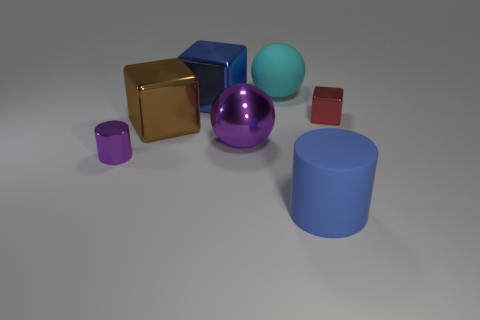What size is the sphere that is behind the object right of the thing in front of the small purple metallic object?
Your answer should be compact. Large. How big is the metal cylinder?
Your answer should be compact. Small. Is there anything else that is the same material as the tiny red thing?
Keep it short and to the point. Yes. There is a ball that is in front of the big blue thing behind the tiny metallic block; are there any purple shiny objects that are in front of it?
Offer a terse response. Yes. How many big things are either rubber balls or brown things?
Ensure brevity in your answer.  2. Is there anything else that is the same color as the tiny cylinder?
Keep it short and to the point. Yes. There is a metal thing that is behind the red thing; is its size the same as the metallic cylinder?
Make the answer very short. No. What color is the big shiny thing that is to the right of the blue thing behind the blue object on the right side of the big cyan sphere?
Provide a short and direct response. Purple. The metallic sphere has what color?
Your response must be concise. Purple. Is the color of the matte ball the same as the small block?
Give a very brief answer. No. 